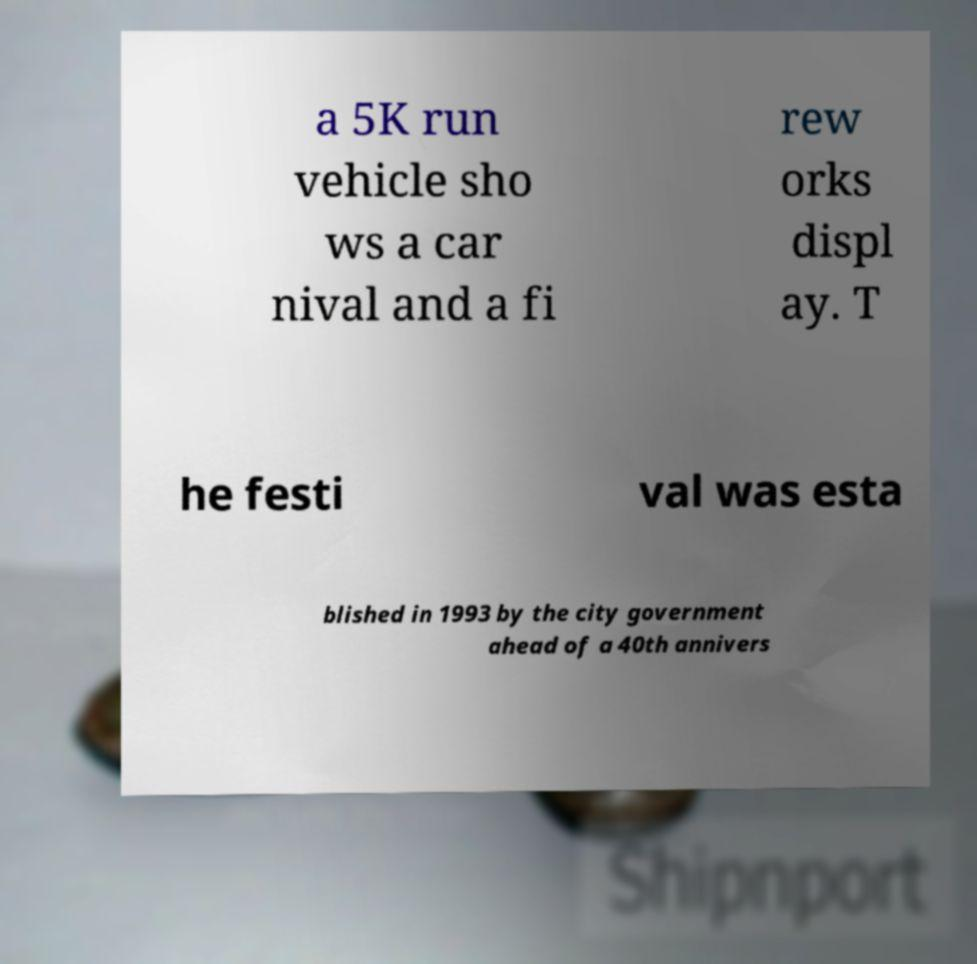Could you extract and type out the text from this image? a 5K run vehicle sho ws a car nival and a fi rew orks displ ay. T he festi val was esta blished in 1993 by the city government ahead of a 40th annivers 